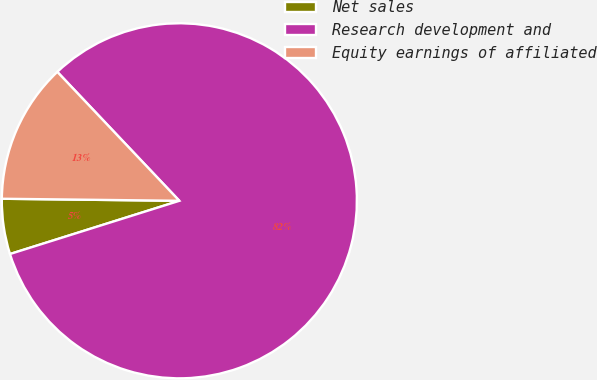<chart> <loc_0><loc_0><loc_500><loc_500><pie_chart><fcel>Net sales<fcel>Research development and<fcel>Equity earnings of affiliated<nl><fcel>5.03%<fcel>82.21%<fcel>12.75%<nl></chart> 